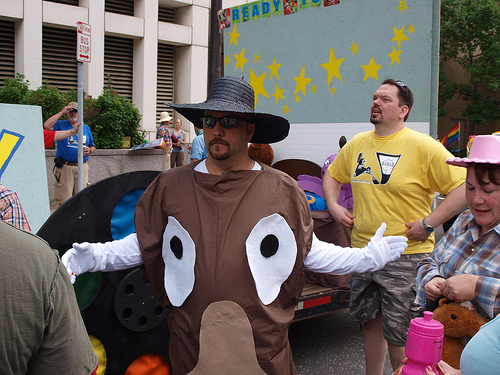<image>
Is the horse on the woman? No. The horse is not positioned on the woman. They may be near each other, but the horse is not supported by or resting on top of the woman. Is there a hat on the man? No. The hat is not positioned on the man. They may be near each other, but the hat is not supported by or resting on top of the man. Is the stars behind the man? Yes. From this viewpoint, the stars is positioned behind the man, with the man partially or fully occluding the stars. Is the wall behind the man? Yes. From this viewpoint, the wall is positioned behind the man, with the man partially or fully occluding the wall. 